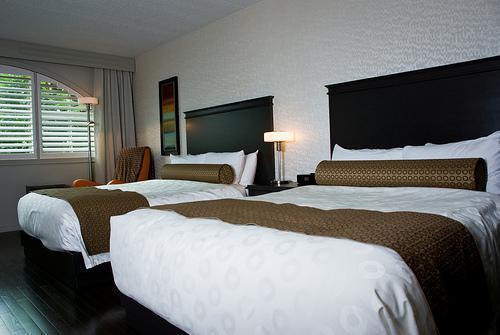How many beds are in the picture?
Give a very brief answer. 2. How many sheep is the dog chasing?
Give a very brief answer. 0. 